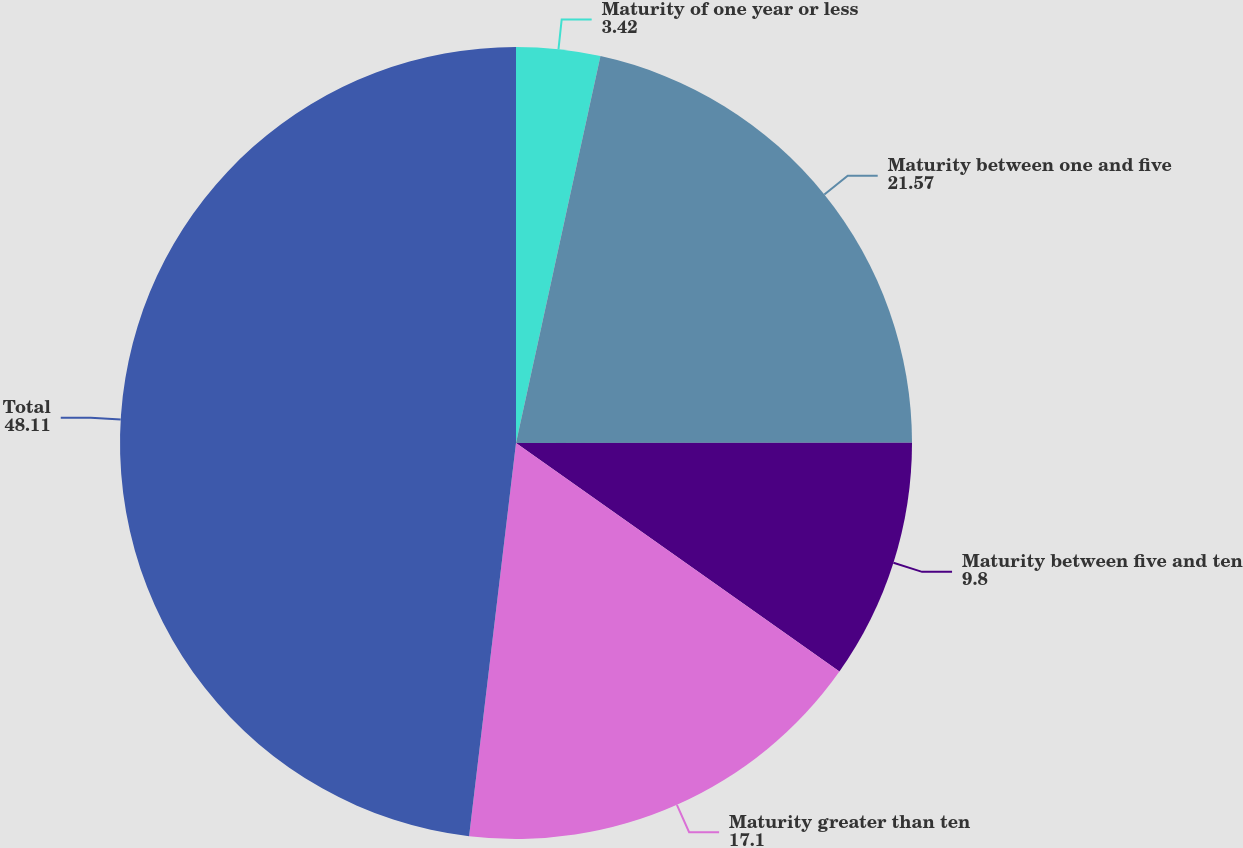<chart> <loc_0><loc_0><loc_500><loc_500><pie_chart><fcel>Maturity of one year or less<fcel>Maturity between one and five<fcel>Maturity between five and ten<fcel>Maturity greater than ten<fcel>Total<nl><fcel>3.42%<fcel>21.57%<fcel>9.8%<fcel>17.1%<fcel>48.11%<nl></chart> 